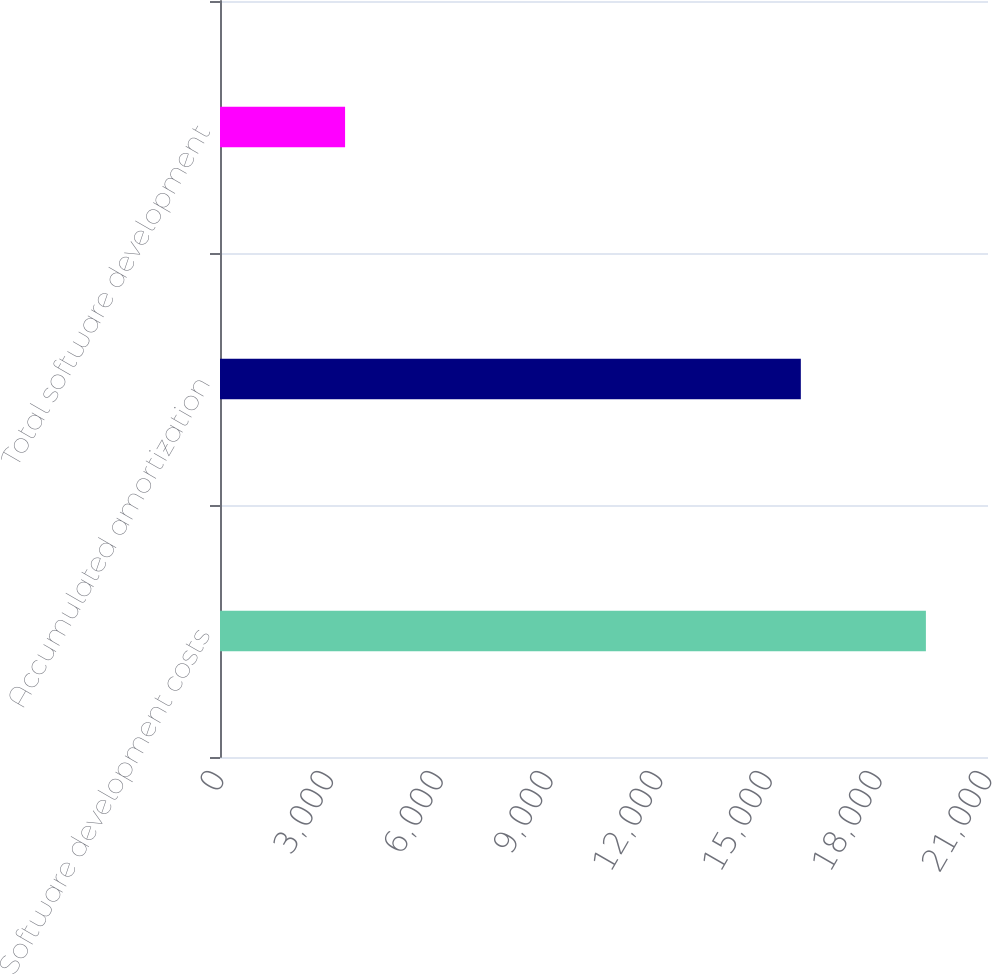Convert chart to OTSL. <chart><loc_0><loc_0><loc_500><loc_500><bar_chart><fcel>Software development costs<fcel>Accumulated amortization<fcel>Total software development<nl><fcel>19302<fcel>15882<fcel>3420<nl></chart> 